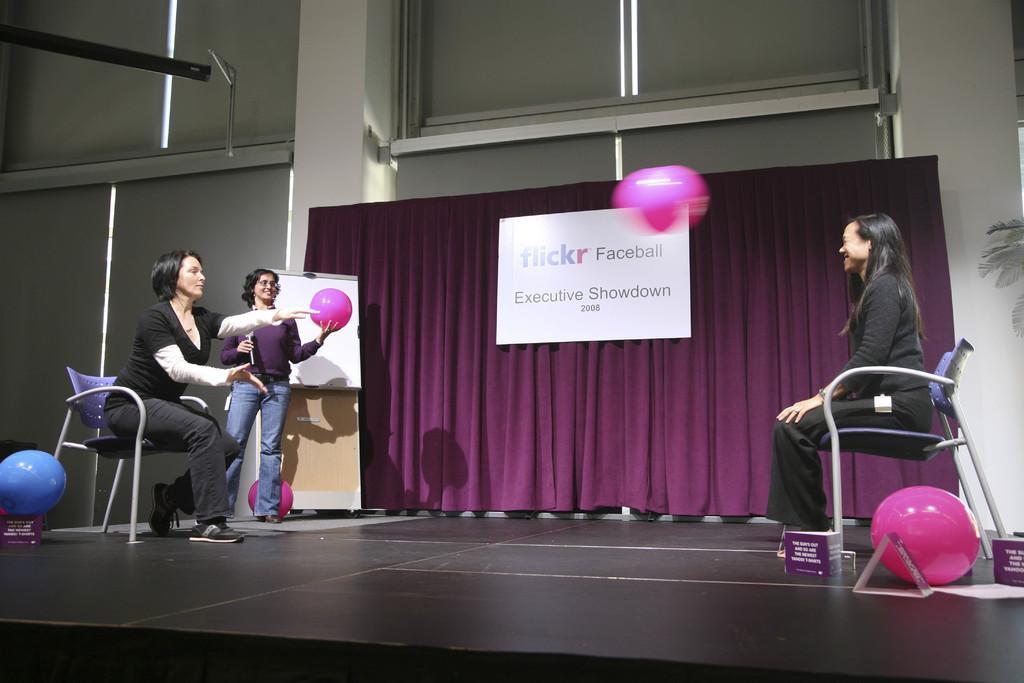Can you describe this image briefly? Woman on the right corner of the picture is sitting on chair and smiling. Beside her, we see a pink balloon. Woman on the right corner of the picture wearing black t-shirt is sitting on chair. Beside her, we see blue balloon and beside her, woman in purple t-shirt is holding pink ball in her hand and beside that, we see a white board and behind these people, we see a sheet which is purple in color and on that, we see a board with some text displayed on it and behind that, we see white pillar and windows. 